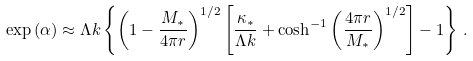Convert formula to latex. <formula><loc_0><loc_0><loc_500><loc_500>\exp { ( \alpha ) } \approx \Lambda k \left \{ \left ( 1 - \frac { M _ { * } } { 4 \pi r } \right ) ^ { 1 / 2 } \left [ \frac { \kappa _ { * } } { \Lambda k } + \cosh ^ { - 1 } \left ( \frac { 4 \pi r } { M _ { * } } \right ) ^ { 1 / 2 } \right ] - 1 \right \} \, .</formula> 